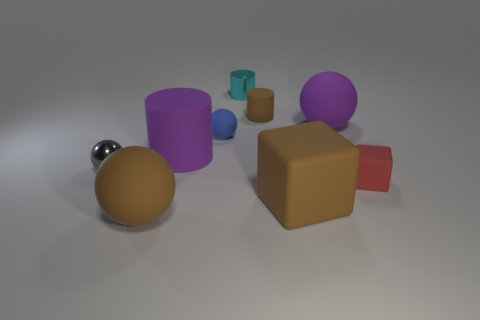There is a gray thing that is the same size as the metallic cylinder; what is its material? The gray object that is approximately the same size as the metallic cylinder appears to be made of a matte plastic material. This inference is based on its lack of reflective sheen which is typical for metal surfaces, compared to the clearly metallic cylinder that reflects light more intensely. 